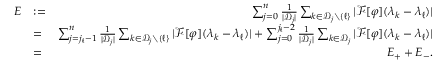Convert formula to latex. <formula><loc_0><loc_0><loc_500><loc_500>\begin{array} { r l r } { E } & { \colon = } & { \sum _ { j = 0 } ^ { n } \frac { 1 } { | { \mathcal { D } } _ { j } | } \sum _ { k \in { \mathcal { D } } _ { j } \ \{ \ell \} } | { \mathcal { F } } [ \varphi ] ( \lambda _ { k } - \lambda _ { \ell } ) | } \\ & { = } & { \sum _ { j = j _ { \ell } - 1 } ^ { n } \frac { 1 } { | { \mathcal { D } } _ { j } | } \sum _ { k \in { \mathcal { D } } _ { j } \ \{ \ell \} } | { \mathcal { F } } [ \varphi ] ( \lambda _ { k } - \lambda _ { \ell } ) | + \sum _ { j = 0 } ^ { j _ { \ell } - 2 } \frac { 1 } { | { \mathcal { D } } _ { j } | } \sum _ { k \in { \mathcal { D } } _ { j } } | { \mathcal { F } } [ \varphi ] ( \lambda _ { k } - \lambda _ { \ell } ) | } \\ & { = } & { E _ { + } + E _ { - } . } \end{array}</formula> 